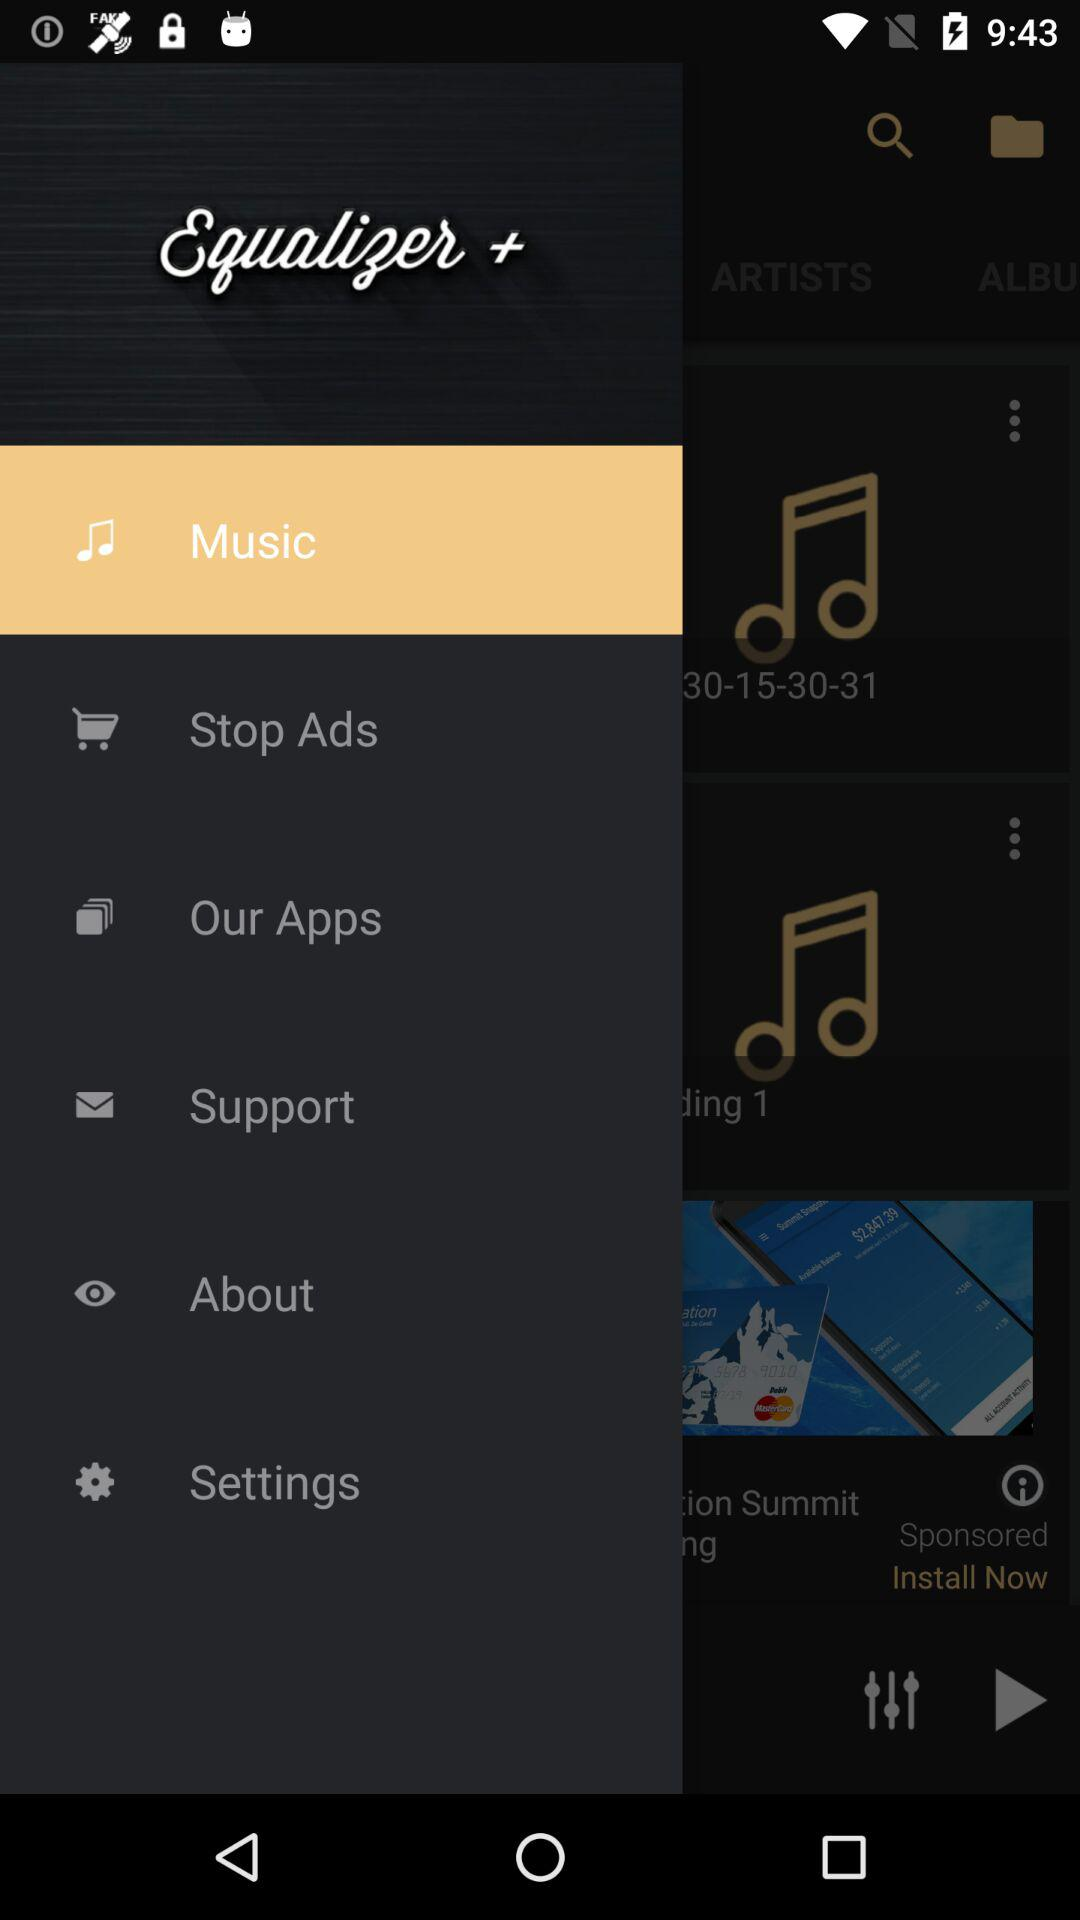What is the selected item? The selected item is "Music". 